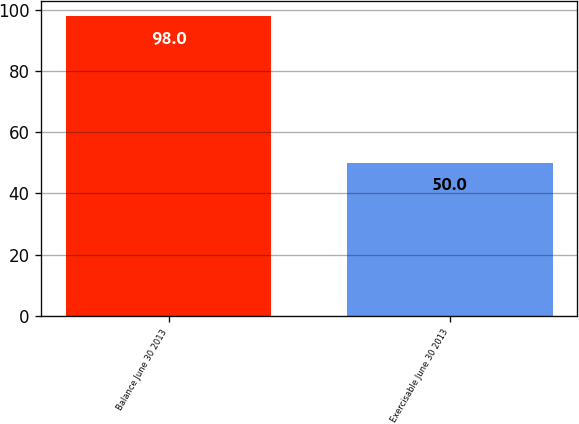Convert chart to OTSL. <chart><loc_0><loc_0><loc_500><loc_500><bar_chart><fcel>Balance June 30 2013<fcel>Exercisable June 30 2013<nl><fcel>98<fcel>50<nl></chart> 